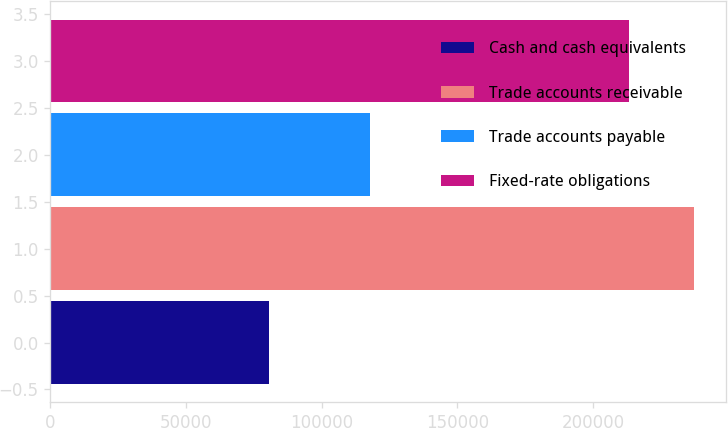Convert chart to OTSL. <chart><loc_0><loc_0><loc_500><loc_500><bar_chart><fcel>Cash and cash equivalents<fcel>Trade accounts receivable<fcel>Trade accounts payable<fcel>Fixed-rate obligations<nl><fcel>80628<fcel>237156<fcel>117931<fcel>213397<nl></chart> 